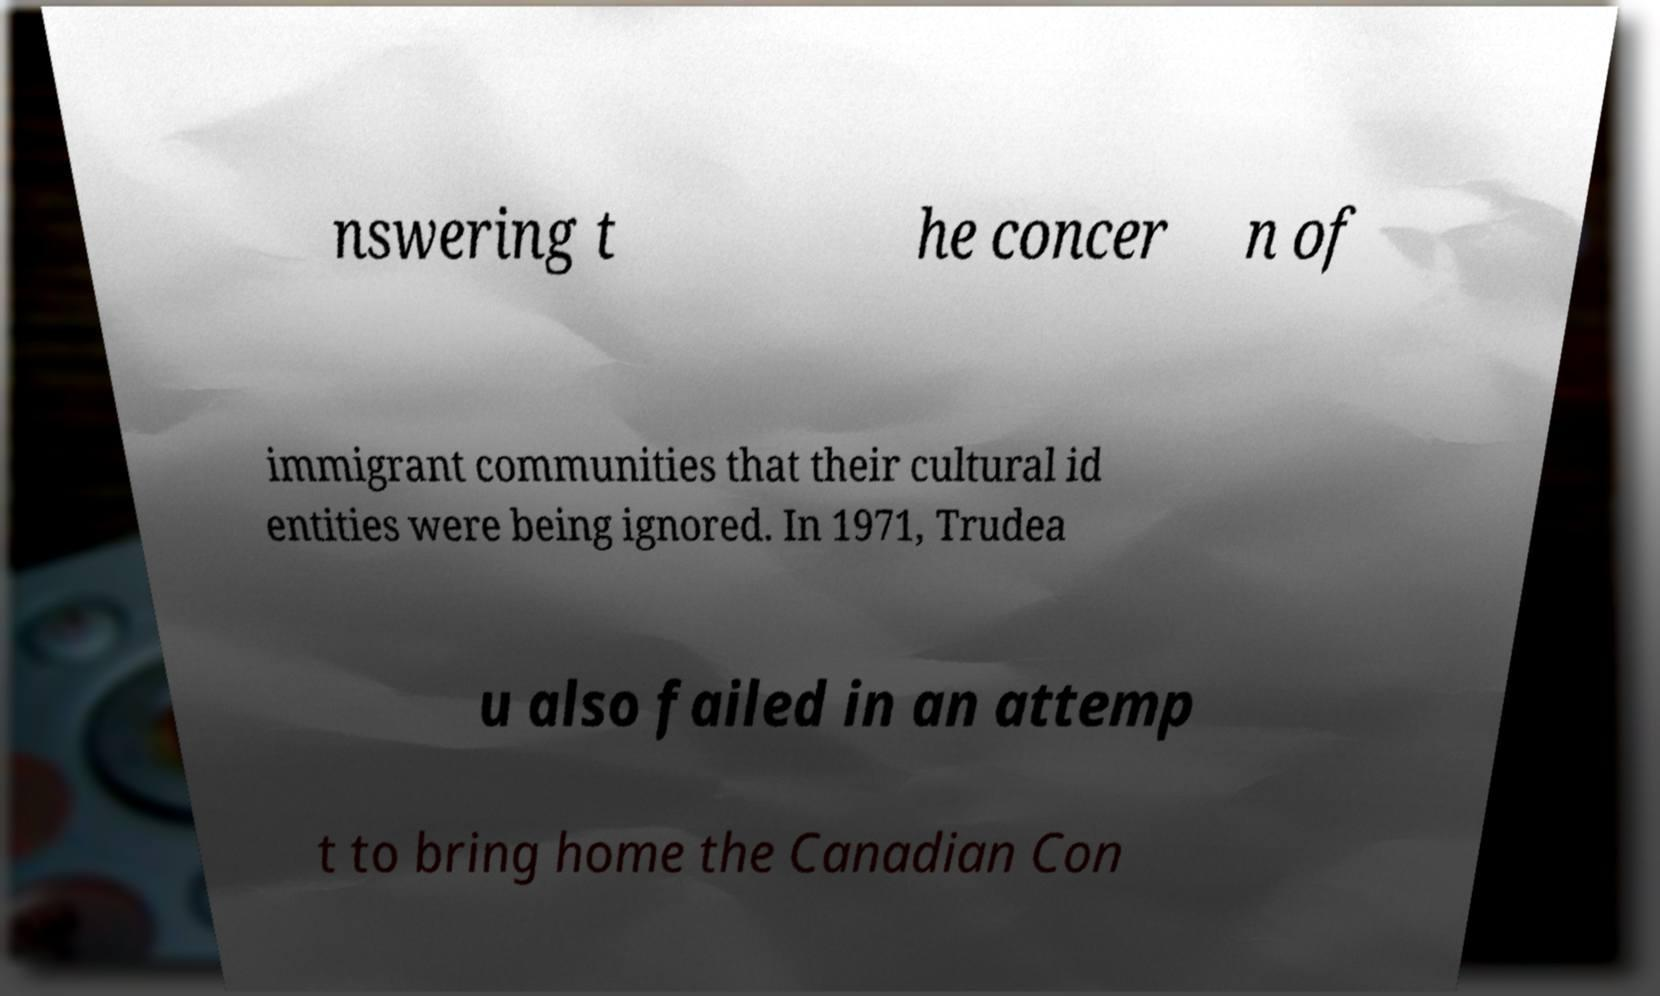There's text embedded in this image that I need extracted. Can you transcribe it verbatim? nswering t he concer n of immigrant communities that their cultural id entities were being ignored. In 1971, Trudea u also failed in an attemp t to bring home the Canadian Con 